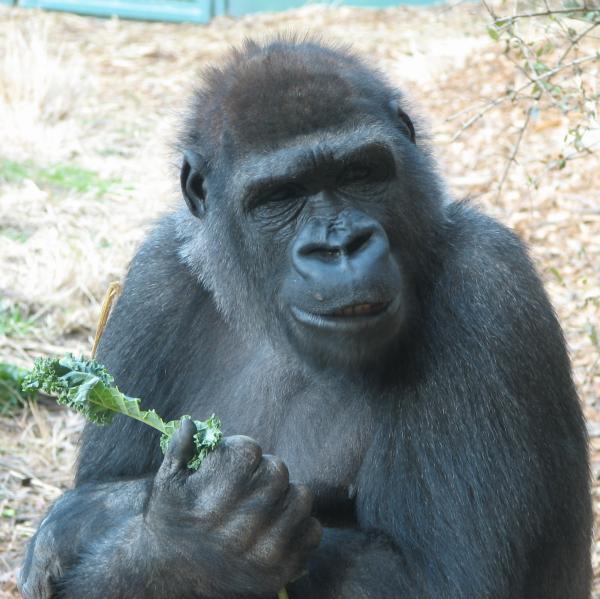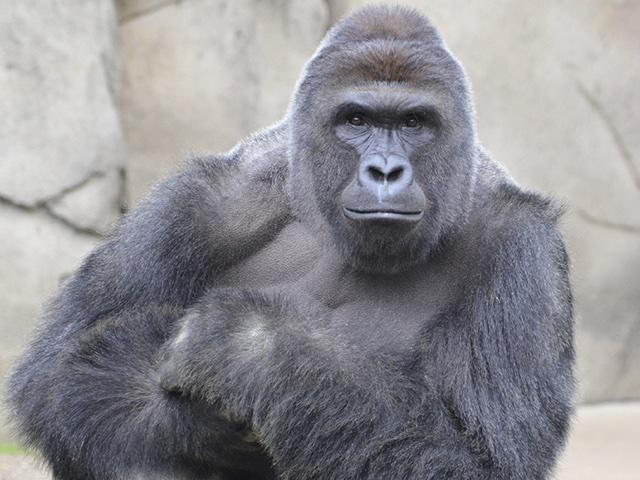The first image is the image on the left, the second image is the image on the right. Evaluate the accuracy of this statement regarding the images: "There are 2 seated gorillas.". Is it true? Answer yes or no. Yes. The first image is the image on the left, the second image is the image on the right. For the images displayed, is the sentence "An image shows a young gorilla close to an adult gorilla." factually correct? Answer yes or no. No. The first image is the image on the left, the second image is the image on the right. Examine the images to the left and right. Is the description "The animal in the image on the left is holding food." accurate? Answer yes or no. Yes. 